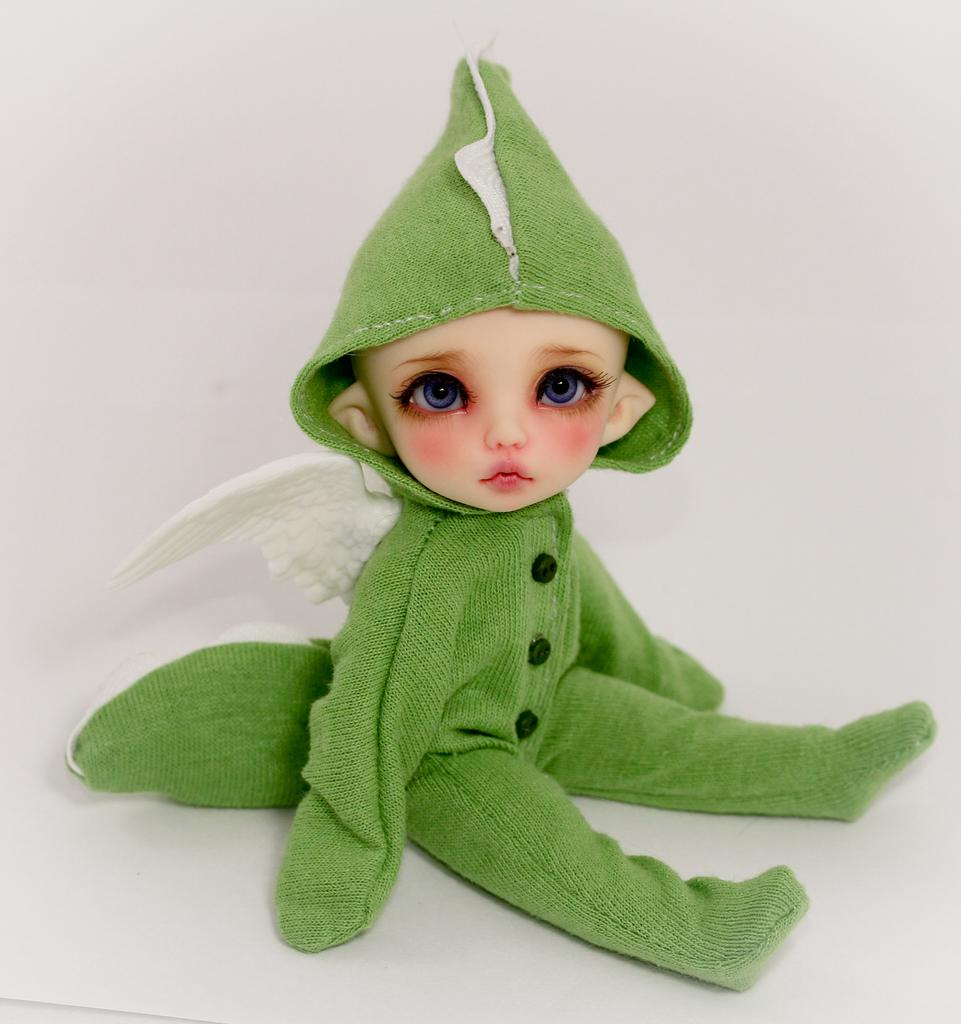What is the main subject of the image? There is a doll in the image. What is the doll wearing? The doll is wearing a green and white color dress. What color is the background of the image? The background of the image is white. Can you see a trail of footprints leading to the doll in the image? There is no trail of footprints visible in the image. What type of nose does the doll have in the image? The image does not show the doll's nose, so it cannot be determined from the image. 